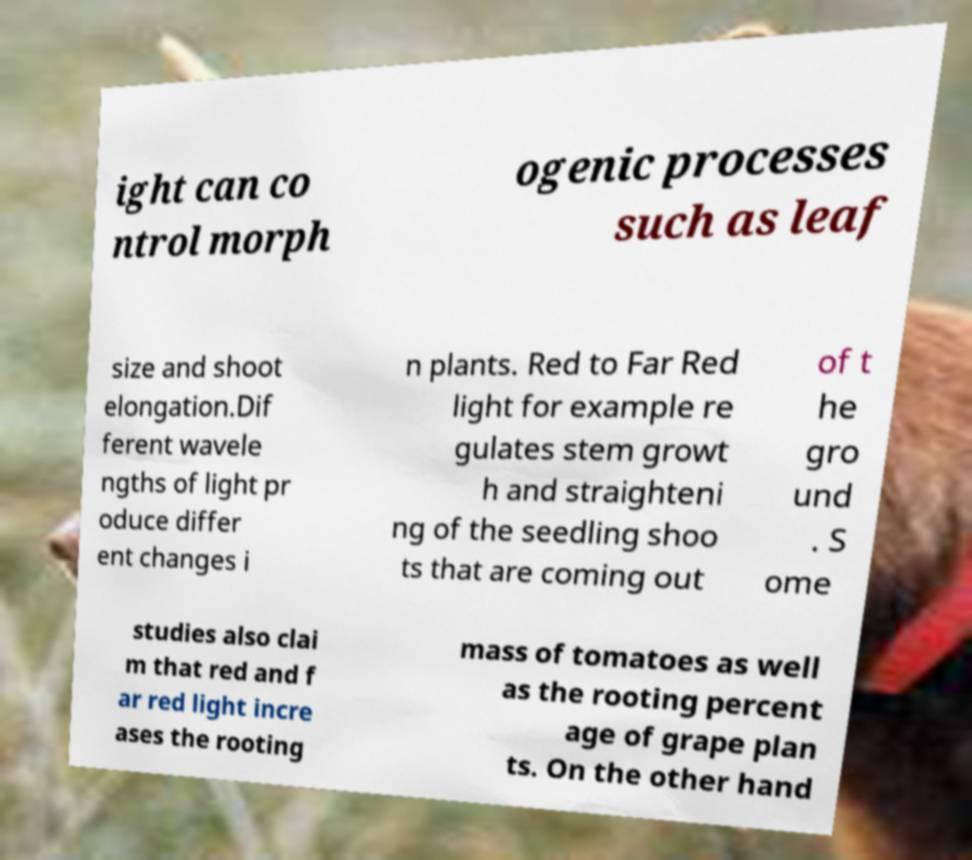There's text embedded in this image that I need extracted. Can you transcribe it verbatim? ight can co ntrol morph ogenic processes such as leaf size and shoot elongation.Dif ferent wavele ngths of light pr oduce differ ent changes i n plants. Red to Far Red light for example re gulates stem growt h and straighteni ng of the seedling shoo ts that are coming out of t he gro und . S ome studies also clai m that red and f ar red light incre ases the rooting mass of tomatoes as well as the rooting percent age of grape plan ts. On the other hand 